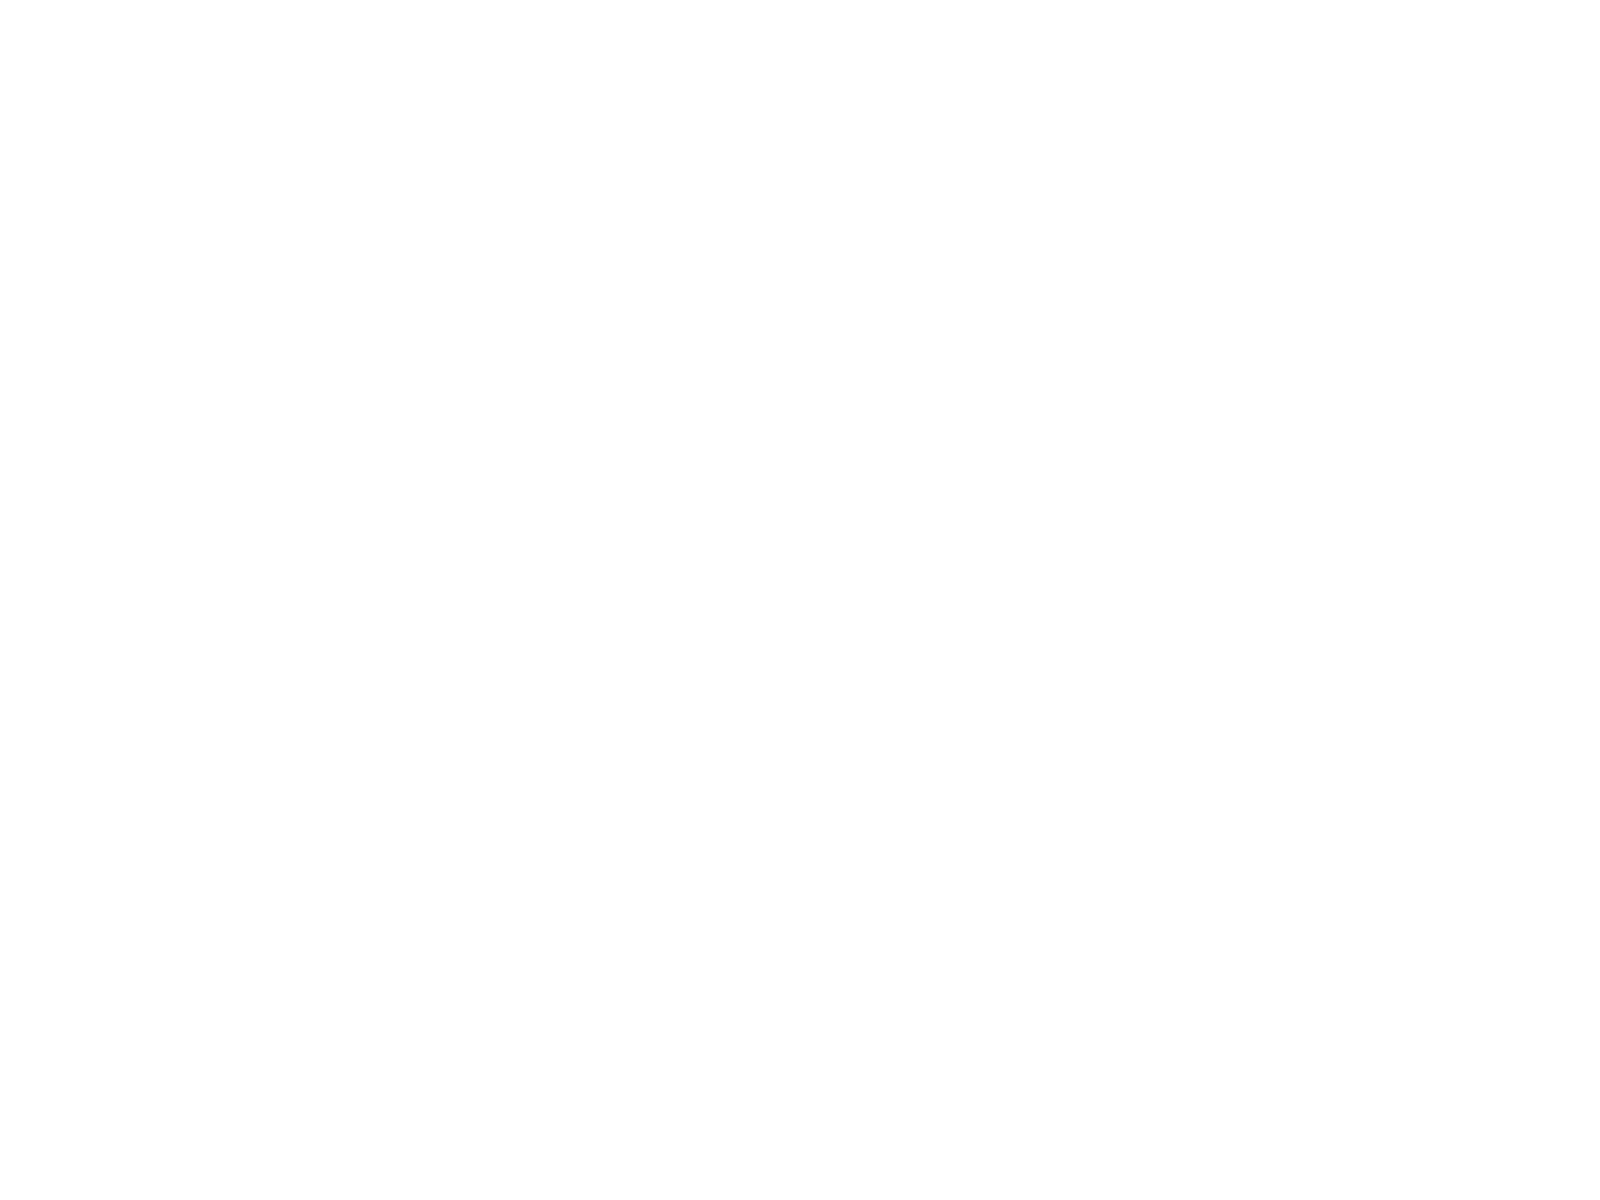<chart> <loc_0><loc_0><loc_500><loc_500><pie_chart><fcel>Total interest income<fcel>Total interest expense and<fcel>Net interest income and other<fcel>Provision for loan losses<fcel>Total non-interest income<fcel>Securities gains net<fcel>Total non-interest expense<fcel>Income from continuing<fcel>Income tax expense<nl><fcel>15.75%<fcel>7.09%<fcel>14.17%<fcel>7.87%<fcel>13.39%<fcel>3.94%<fcel>16.54%<fcel>12.6%<fcel>8.66%<nl></chart> 